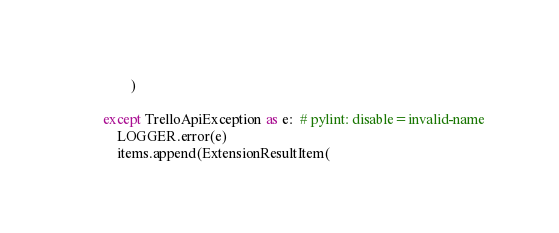<code> <loc_0><loc_0><loc_500><loc_500><_Python_>                )

        except TrelloApiException as e:  # pylint: disable=invalid-name
            LOGGER.error(e)
            items.append(ExtensionResultItem(</code> 